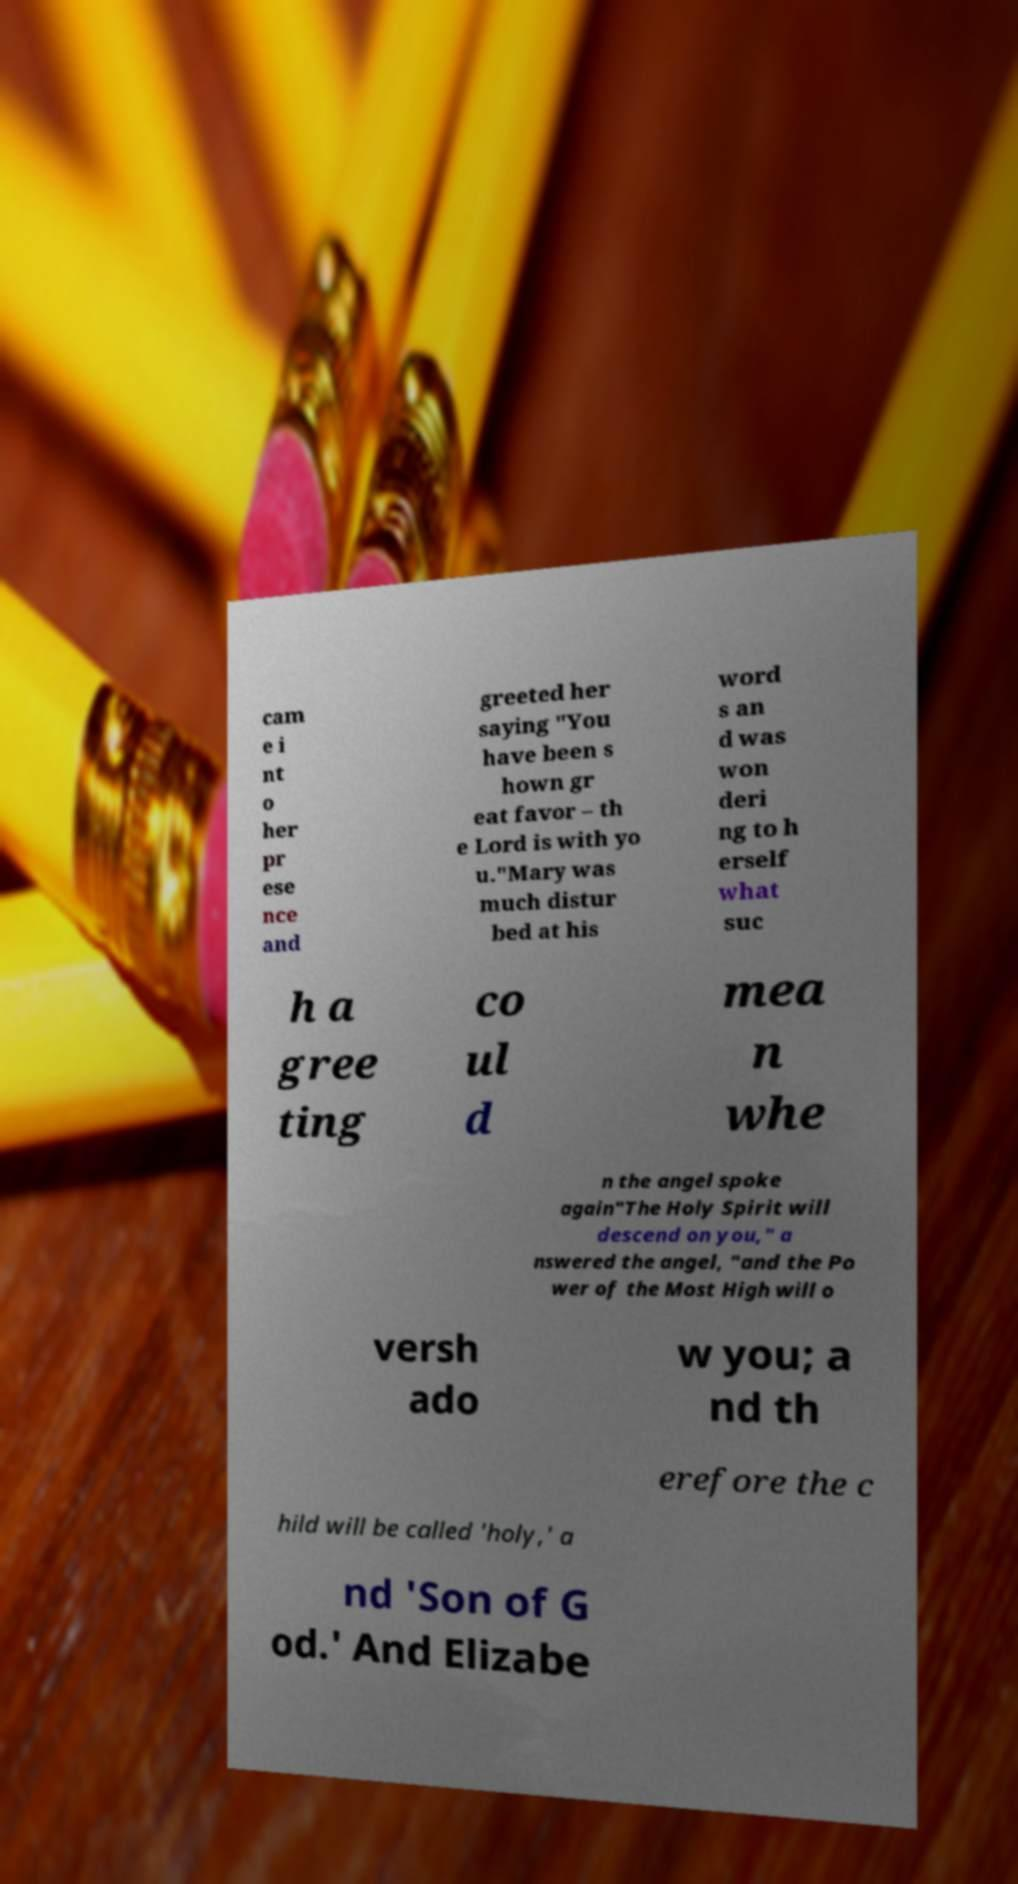Can you read and provide the text displayed in the image?This photo seems to have some interesting text. Can you extract and type it out for me? cam e i nt o her pr ese nce and greeted her saying "You have been s hown gr eat favor – th e Lord is with yo u."Mary was much distur bed at his word s an d was won deri ng to h erself what suc h a gree ting co ul d mea n whe n the angel spoke again"The Holy Spirit will descend on you," a nswered the angel, "and the Po wer of the Most High will o versh ado w you; a nd th erefore the c hild will be called 'holy,' a nd 'Son of G od.' And Elizabe 